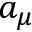Convert formula to latex. <formula><loc_0><loc_0><loc_500><loc_500>a _ { \mu }</formula> 